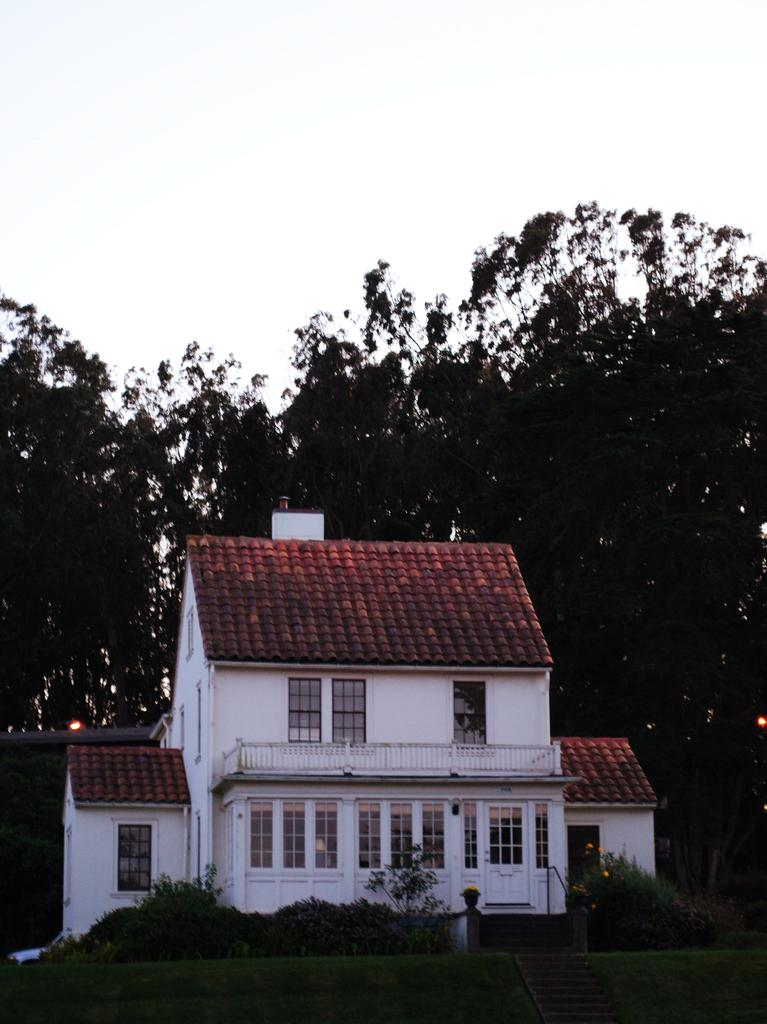What type of structure is visible in the image? There is a beautiful house in the image. What is located in front of the house? There is a garden in front of the house. What can be seen in the background of the image? There are plenty of trees in the background of the image. What type of scientific experiment is being conducted in the jar in the image? There is no jar or scientific experiment present in the image. 